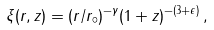Convert formula to latex. <formula><loc_0><loc_0><loc_500><loc_500>\xi ( r , z ) = ( r / r _ { \circ } ) ^ { - \gamma } ( 1 + z ) ^ { - ( 3 + \epsilon ) } \, ,</formula> 